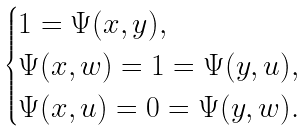Convert formula to latex. <formula><loc_0><loc_0><loc_500><loc_500>\begin{cases} 1 = \Psi ( x , y ) , \\ \Psi ( x , w ) = 1 = \Psi ( y , u ) , \\ \Psi ( x , u ) = 0 = \Psi ( y , w ) . \end{cases}</formula> 